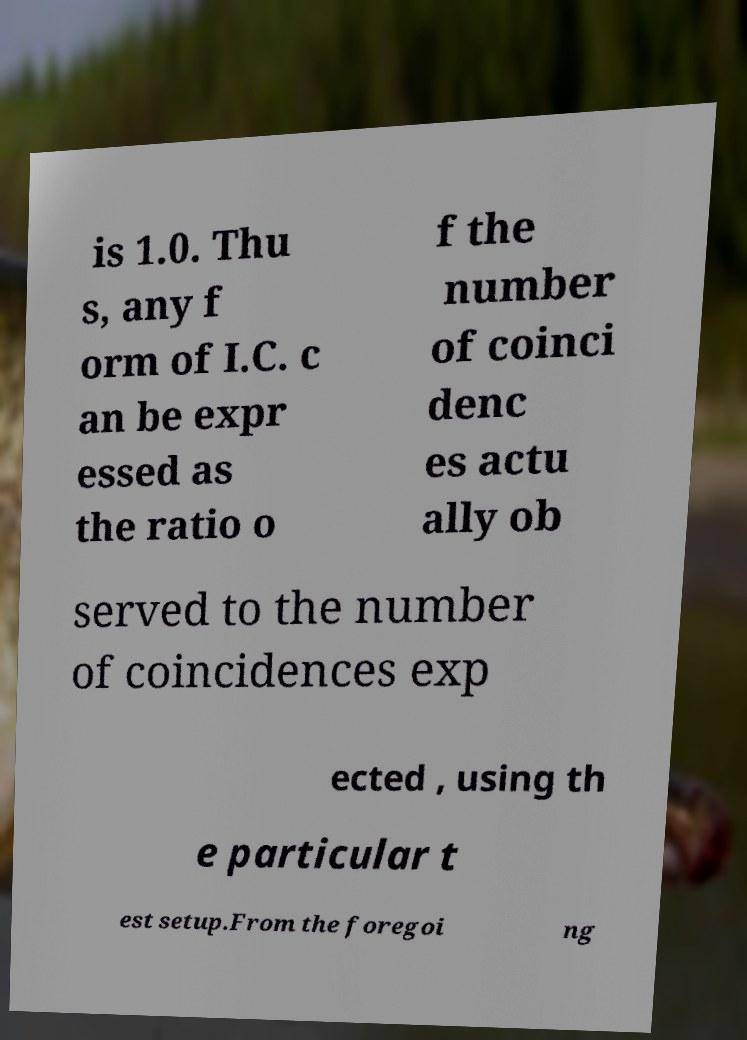Please read and relay the text visible in this image. What does it say? is 1.0. Thu s, any f orm of I.C. c an be expr essed as the ratio o f the number of coinci denc es actu ally ob served to the number of coincidences exp ected , using th e particular t est setup.From the foregoi ng 